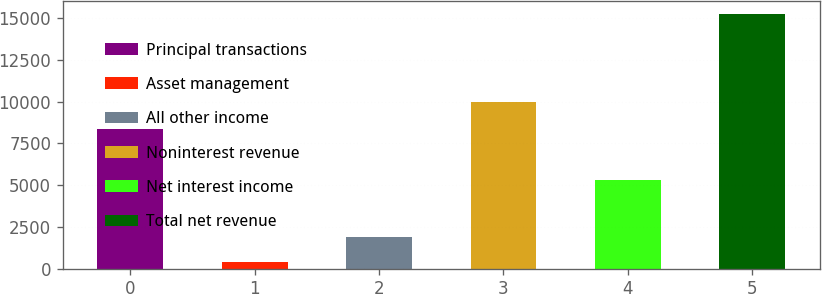Convert chart to OTSL. <chart><loc_0><loc_0><loc_500><loc_500><bar_chart><fcel>Principal transactions<fcel>Asset management<fcel>All other income<fcel>Noninterest revenue<fcel>Net interest income<fcel>Total net revenue<nl><fcel>8347<fcel>388<fcel>1875.1<fcel>9969<fcel>5290<fcel>15259<nl></chart> 